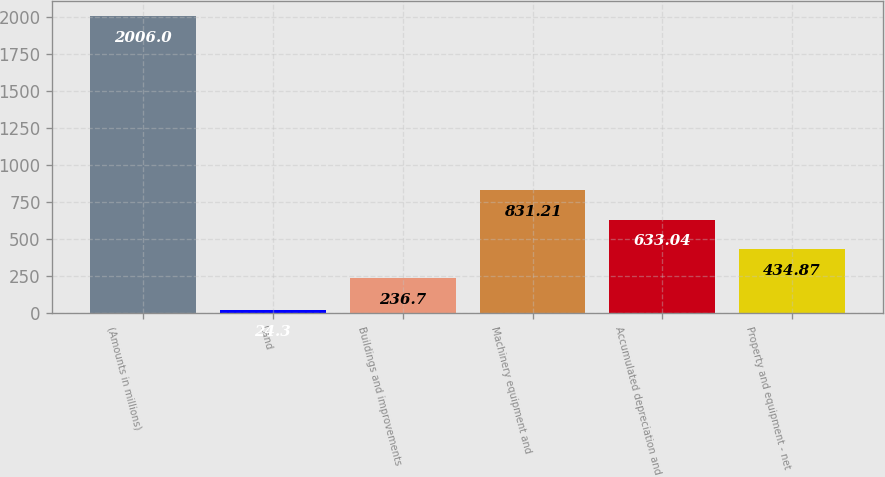<chart> <loc_0><loc_0><loc_500><loc_500><bar_chart><fcel>(Amounts in millions)<fcel>Land<fcel>Buildings and improvements<fcel>Machinery equipment and<fcel>Accumulated depreciation and<fcel>Property and equipment - net<nl><fcel>2006<fcel>24.3<fcel>236.7<fcel>831.21<fcel>633.04<fcel>434.87<nl></chart> 